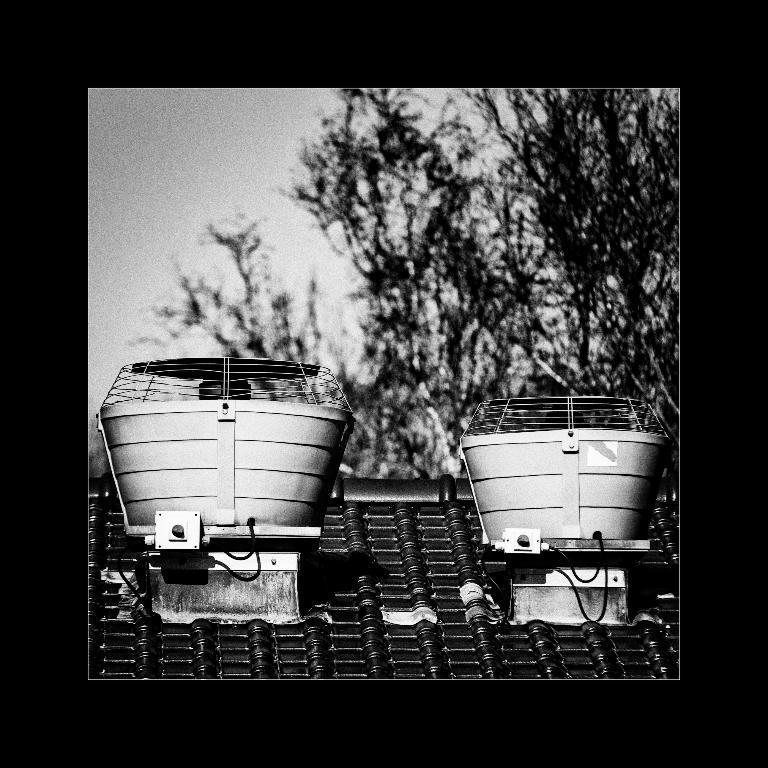Can you describe this image briefly? In this picture we can observe two lights on the top of the building. We can observe a fence on the top of the two lights. In the background there are trees and a sky. This is a black and white image. 